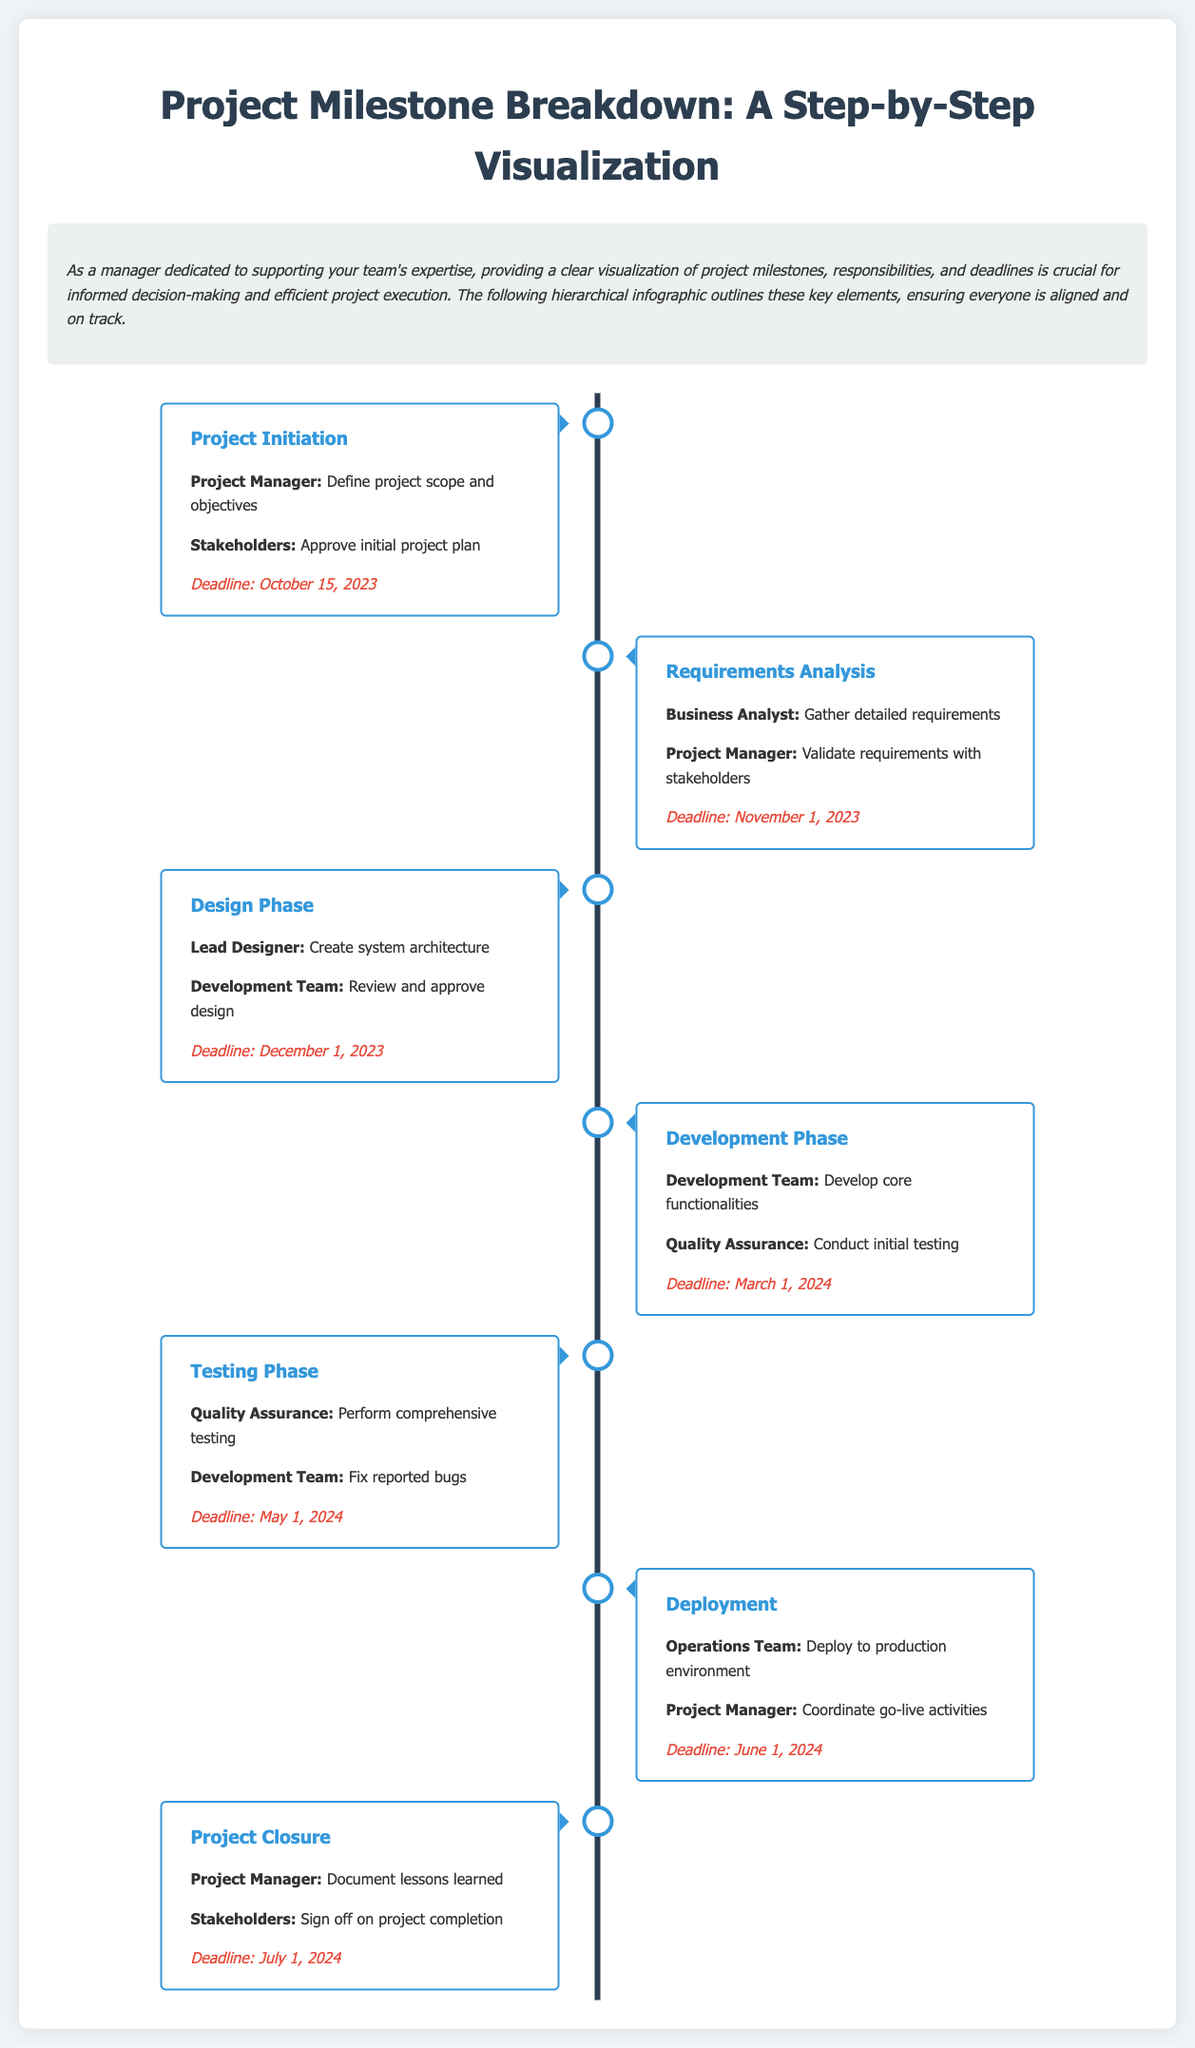What is the first milestone? The first milestone in the timeline is listed first in the document as "Project Initiation."
Answer: Project Initiation Who is responsible for gathering detailed requirements? The responsibility for gathering detailed requirements is assigned to the "Business Analyst."
Answer: Business Analyst What is the deadline for the Design Phase? The deadline for the Design Phase is clearly stated in the document as December 1, 2023.
Answer: December 1, 2023 What is the main responsibility of the Quality Assurance team during the Testing Phase? The main responsibility during the Testing Phase is indicated as "Perform comprehensive testing."
Answer: Perform comprehensive testing How many milestones are there in total? The total number of milestones is determined by counting each listed milestone in the timeline, which totals to six.
Answer: Six What milestone comes after the Development Phase? The milestone that follows the Development Phase can be identified as "Testing Phase."
Answer: Testing Phase Which role is responsible for coordinating go-live activities? The role responsible for coordinating go-live activities, as stated in the document, is the "Project Manager."
Answer: Project Manager What is the last milestone listed? The last milestone listed in the document is "Project Closure."
Answer: Project Closure 